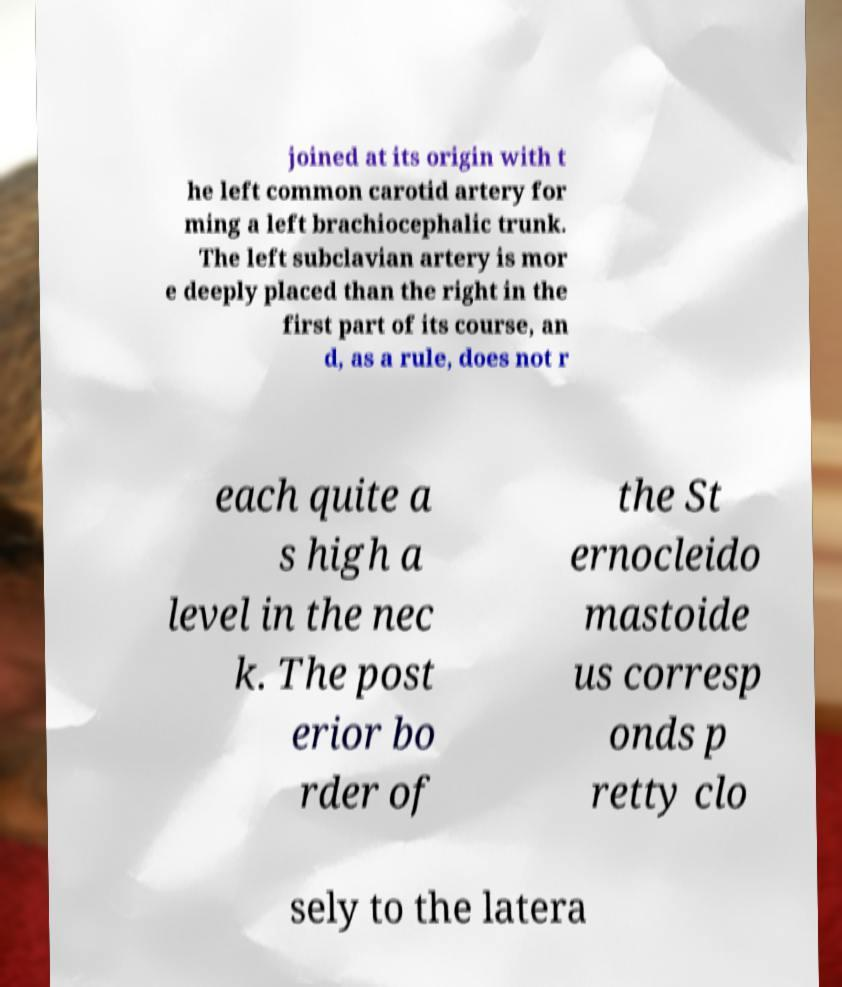Please identify and transcribe the text found in this image. joined at its origin with t he left common carotid artery for ming a left brachiocephalic trunk. The left subclavian artery is mor e deeply placed than the right in the first part of its course, an d, as a rule, does not r each quite a s high a level in the nec k. The post erior bo rder of the St ernocleido mastoide us corresp onds p retty clo sely to the latera 